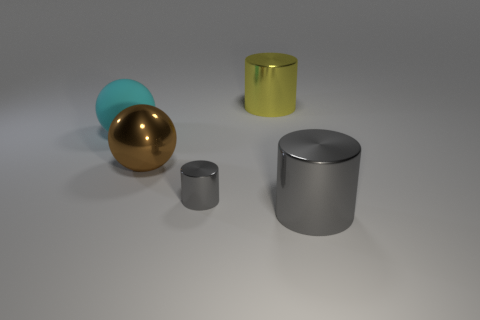How many cylinders are made of the same material as the big brown thing?
Your response must be concise. 3. There is a big metallic cylinder that is in front of the rubber thing; what number of gray things are behind it?
Offer a very short reply. 1. What number of large purple spheres are there?
Keep it short and to the point. 0. Do the cyan ball and the large cylinder on the right side of the yellow shiny cylinder have the same material?
Offer a very short reply. No. There is a large metallic cylinder behind the tiny thing; is it the same color as the metal ball?
Offer a very short reply. No. What is the thing that is both behind the big brown metallic sphere and to the left of the tiny cylinder made of?
Give a very brief answer. Rubber. The yellow metal cylinder is what size?
Your answer should be very brief. Large. There is a small shiny object; is it the same color as the big shiny object that is in front of the tiny gray cylinder?
Make the answer very short. Yes. How many other things are the same color as the tiny object?
Provide a succinct answer. 1. There is a object behind the big cyan thing; does it have the same size as the gray object that is on the left side of the large gray shiny cylinder?
Give a very brief answer. No. 